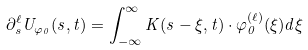<formula> <loc_0><loc_0><loc_500><loc_500>\partial _ { s } ^ { \ell } U _ { \varphi _ { 0 } } ( s , t ) = \int _ { - \infty } ^ { \infty } K ( s - \xi , t ) \cdot \varphi _ { 0 } ^ { ( \ell ) } ( \xi ) d \xi</formula> 